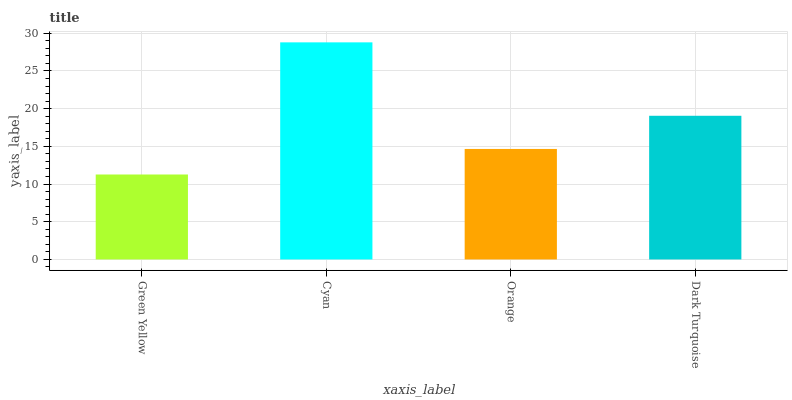Is Green Yellow the minimum?
Answer yes or no. Yes. Is Cyan the maximum?
Answer yes or no. Yes. Is Orange the minimum?
Answer yes or no. No. Is Orange the maximum?
Answer yes or no. No. Is Cyan greater than Orange?
Answer yes or no. Yes. Is Orange less than Cyan?
Answer yes or no. Yes. Is Orange greater than Cyan?
Answer yes or no. No. Is Cyan less than Orange?
Answer yes or no. No. Is Dark Turquoise the high median?
Answer yes or no. Yes. Is Orange the low median?
Answer yes or no. Yes. Is Cyan the high median?
Answer yes or no. No. Is Green Yellow the low median?
Answer yes or no. No. 